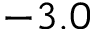Convert formula to latex. <formula><loc_0><loc_0><loc_500><loc_500>- 3 . 0</formula> 